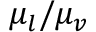Convert formula to latex. <formula><loc_0><loc_0><loc_500><loc_500>{ \mu _ { l } } / { \mu _ { v } }</formula> 